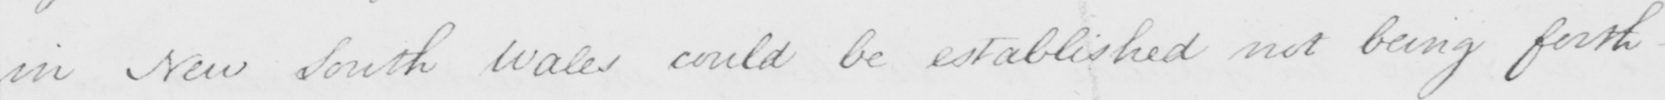What is written in this line of handwriting? in New South Wales could be established not being forth- 